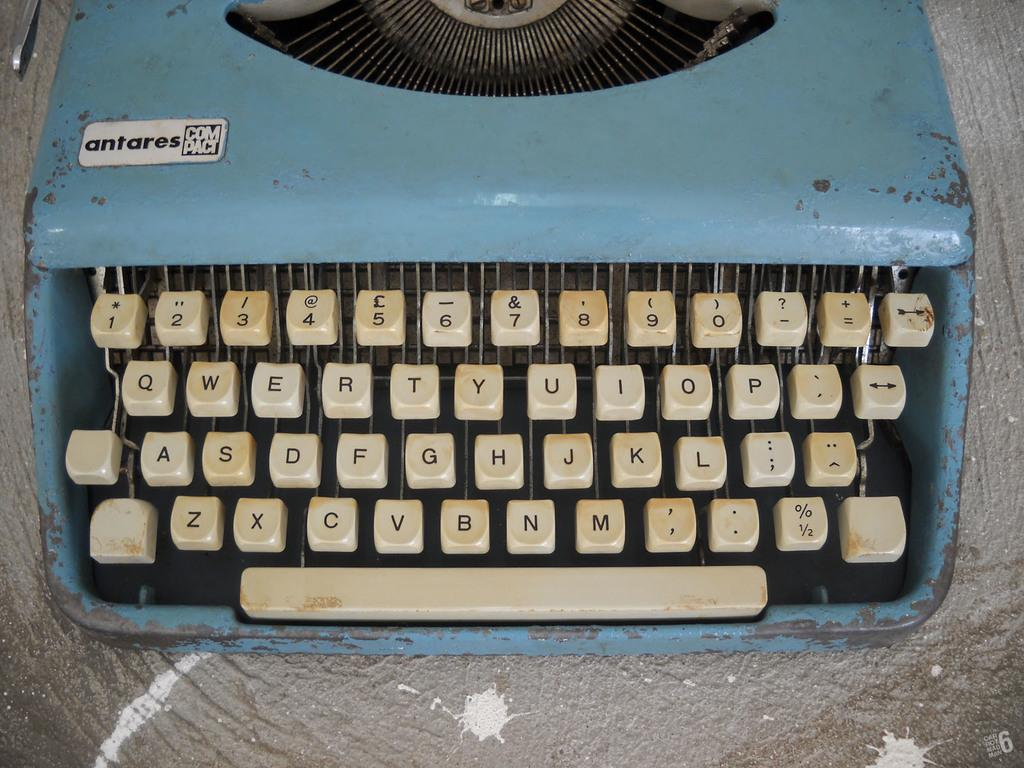<image>
Present a compact description of the photo's key features. The blue typewriter, which is a compact antares, is sitting on a scratched and dirty table. 